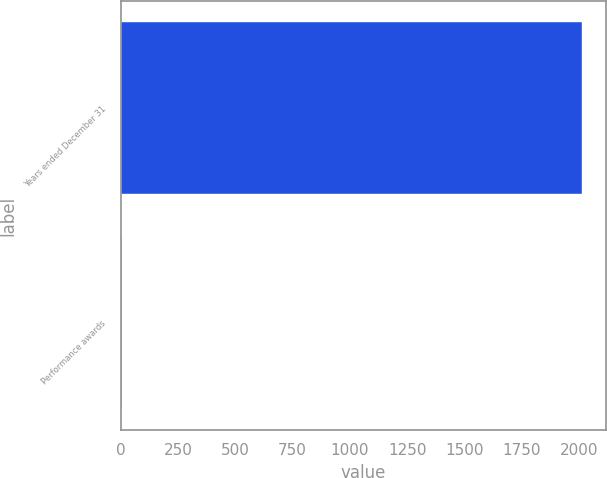<chart> <loc_0><loc_0><loc_500><loc_500><bar_chart><fcel>Years ended December 31<fcel>Performance awards<nl><fcel>2015<fcel>5.6<nl></chart> 